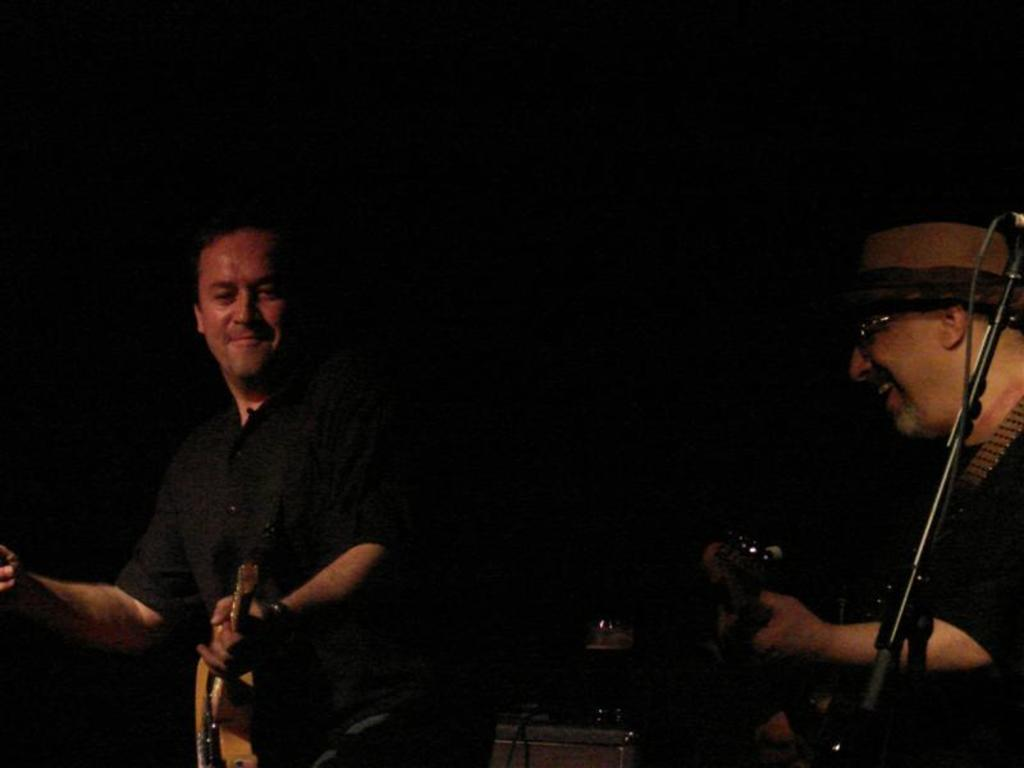How many people are in the image? There are two people in the image. What are the two people doing in the image? The two people are playing musical instruments. What type of oil is being used by the people in the image? There is no oil present in the image; the two people are playing musical instruments. What is the size of the touch screen in the image? There is no touch screen present in the image; it features two people playing musical instruments. 